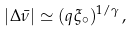<formula> <loc_0><loc_0><loc_500><loc_500>| \Delta \bar { \nu } | \simeq ( q \xi _ { \circ } ) ^ { 1 / \gamma } \, ,</formula> 